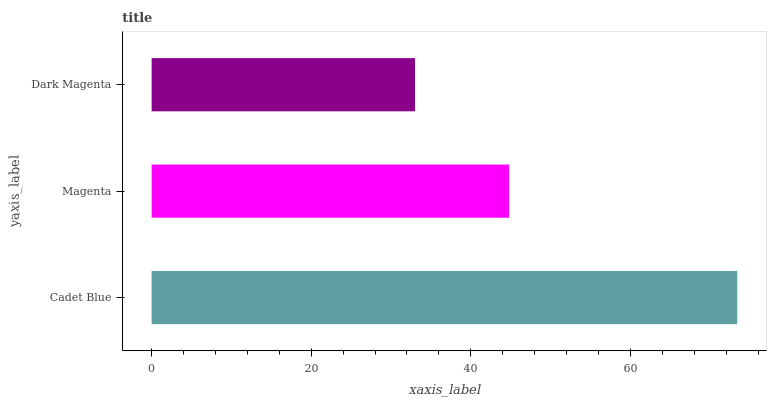Is Dark Magenta the minimum?
Answer yes or no. Yes. Is Cadet Blue the maximum?
Answer yes or no. Yes. Is Magenta the minimum?
Answer yes or no. No. Is Magenta the maximum?
Answer yes or no. No. Is Cadet Blue greater than Magenta?
Answer yes or no. Yes. Is Magenta less than Cadet Blue?
Answer yes or no. Yes. Is Magenta greater than Cadet Blue?
Answer yes or no. No. Is Cadet Blue less than Magenta?
Answer yes or no. No. Is Magenta the high median?
Answer yes or no. Yes. Is Magenta the low median?
Answer yes or no. Yes. Is Cadet Blue the high median?
Answer yes or no. No. Is Dark Magenta the low median?
Answer yes or no. No. 